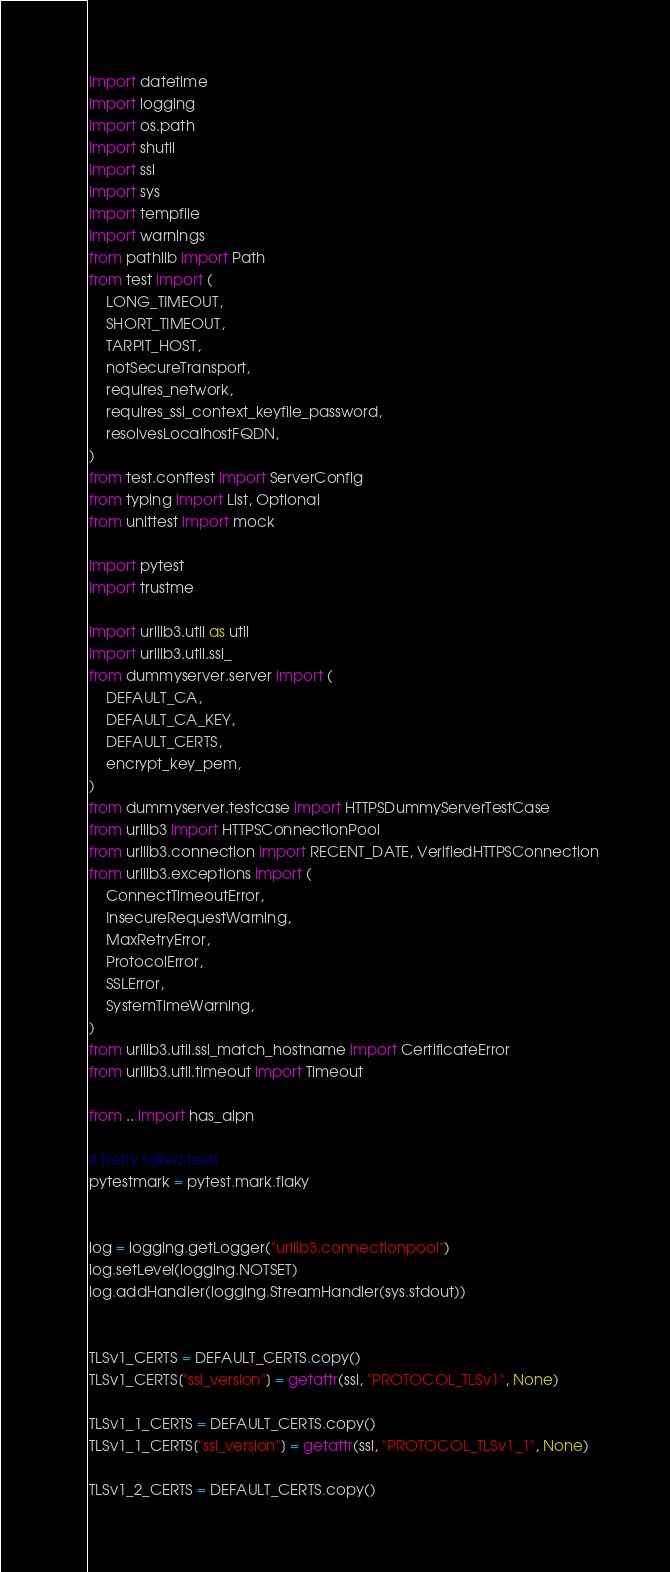<code> <loc_0><loc_0><loc_500><loc_500><_Python_>import datetime
import logging
import os.path
import shutil
import ssl
import sys
import tempfile
import warnings
from pathlib import Path
from test import (
    LONG_TIMEOUT,
    SHORT_TIMEOUT,
    TARPIT_HOST,
    notSecureTransport,
    requires_network,
    requires_ssl_context_keyfile_password,
    resolvesLocalhostFQDN,
)
from test.conftest import ServerConfig
from typing import List, Optional
from unittest import mock

import pytest
import trustme

import urllib3.util as util
import urllib3.util.ssl_
from dummyserver.server import (
    DEFAULT_CA,
    DEFAULT_CA_KEY,
    DEFAULT_CERTS,
    encrypt_key_pem,
)
from dummyserver.testcase import HTTPSDummyServerTestCase
from urllib3 import HTTPSConnectionPool
from urllib3.connection import RECENT_DATE, VerifiedHTTPSConnection
from urllib3.exceptions import (
    ConnectTimeoutError,
    InsecureRequestWarning,
    MaxRetryError,
    ProtocolError,
    SSLError,
    SystemTimeWarning,
)
from urllib3.util.ssl_match_hostname import CertificateError
from urllib3.util.timeout import Timeout

from .. import has_alpn

# Retry failed tests
pytestmark = pytest.mark.flaky


log = logging.getLogger("urllib3.connectionpool")
log.setLevel(logging.NOTSET)
log.addHandler(logging.StreamHandler(sys.stdout))


TLSv1_CERTS = DEFAULT_CERTS.copy()
TLSv1_CERTS["ssl_version"] = getattr(ssl, "PROTOCOL_TLSv1", None)

TLSv1_1_CERTS = DEFAULT_CERTS.copy()
TLSv1_1_CERTS["ssl_version"] = getattr(ssl, "PROTOCOL_TLSv1_1", None)

TLSv1_2_CERTS = DEFAULT_CERTS.copy()</code> 